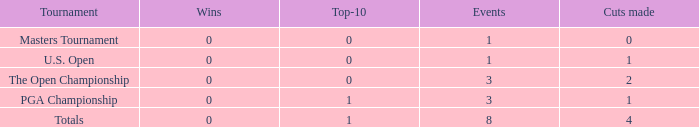For players who have participated in at least 8 major events and made more than 1 cut, what is the highest number of top-10 finishes achieved? 1.0. 